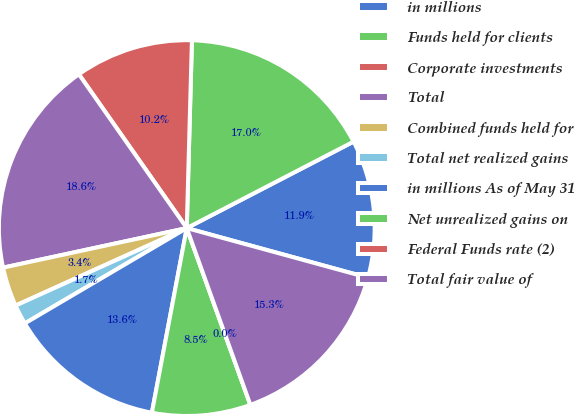Convert chart. <chart><loc_0><loc_0><loc_500><loc_500><pie_chart><fcel>in millions<fcel>Funds held for clients<fcel>Corporate investments<fcel>Total<fcel>Combined funds held for<fcel>Total net realized gains<fcel>in millions As of May 31<fcel>Net unrealized gains on<fcel>Federal Funds rate (2)<fcel>Total fair value of<nl><fcel>11.86%<fcel>16.95%<fcel>10.17%<fcel>18.64%<fcel>3.39%<fcel>1.7%<fcel>13.56%<fcel>8.47%<fcel>0.0%<fcel>15.25%<nl></chart> 